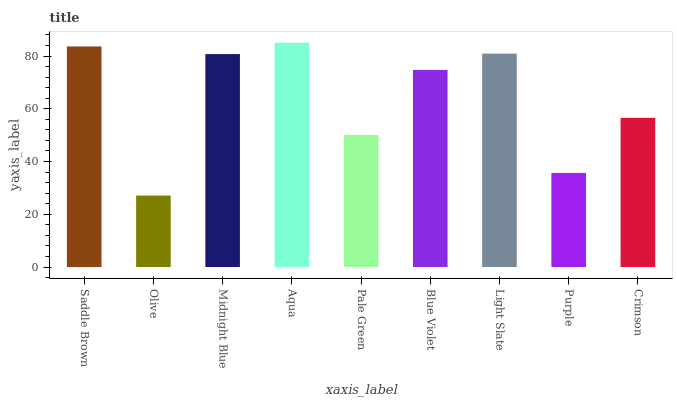Is Olive the minimum?
Answer yes or no. Yes. Is Aqua the maximum?
Answer yes or no. Yes. Is Midnight Blue the minimum?
Answer yes or no. No. Is Midnight Blue the maximum?
Answer yes or no. No. Is Midnight Blue greater than Olive?
Answer yes or no. Yes. Is Olive less than Midnight Blue?
Answer yes or no. Yes. Is Olive greater than Midnight Blue?
Answer yes or no. No. Is Midnight Blue less than Olive?
Answer yes or no. No. Is Blue Violet the high median?
Answer yes or no. Yes. Is Blue Violet the low median?
Answer yes or no. Yes. Is Purple the high median?
Answer yes or no. No. Is Saddle Brown the low median?
Answer yes or no. No. 